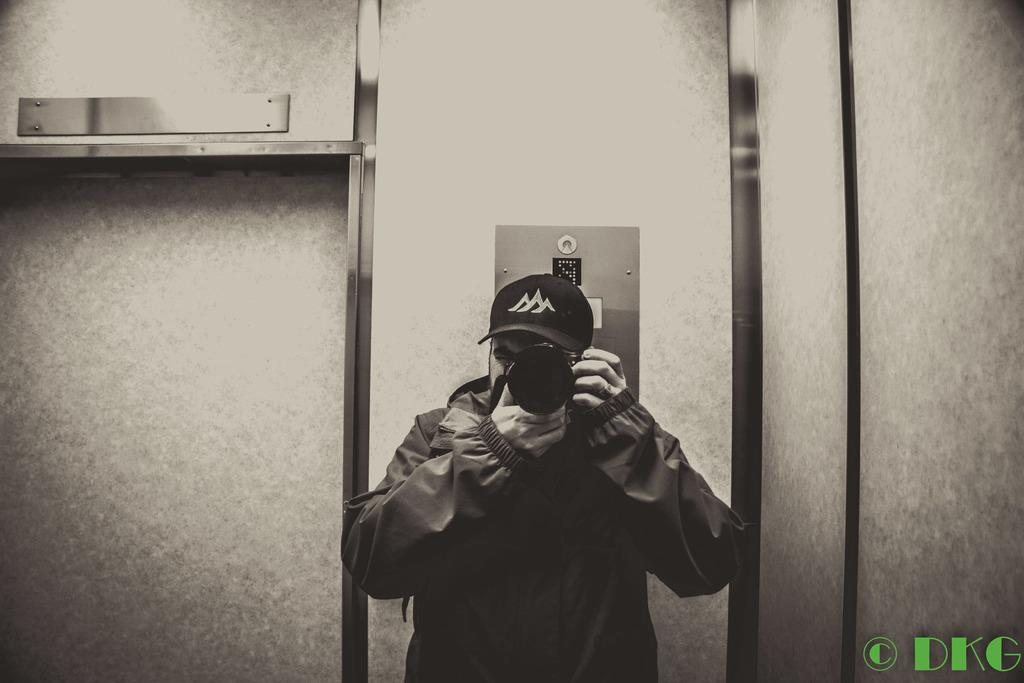Who is present in the image? There is a man in the image. What is the man holding in the image? The man is holding a camera. What can be seen in the background of the image? There is a wall and a lift in the background of the image. Is there any text visible in the image? Yes, there is some text in the bottom right corner of the image. How many crates are stacked next to the man in the image? There are no crates present in the image. What type of horse can be seen in the image? There is no horse present in the image. 